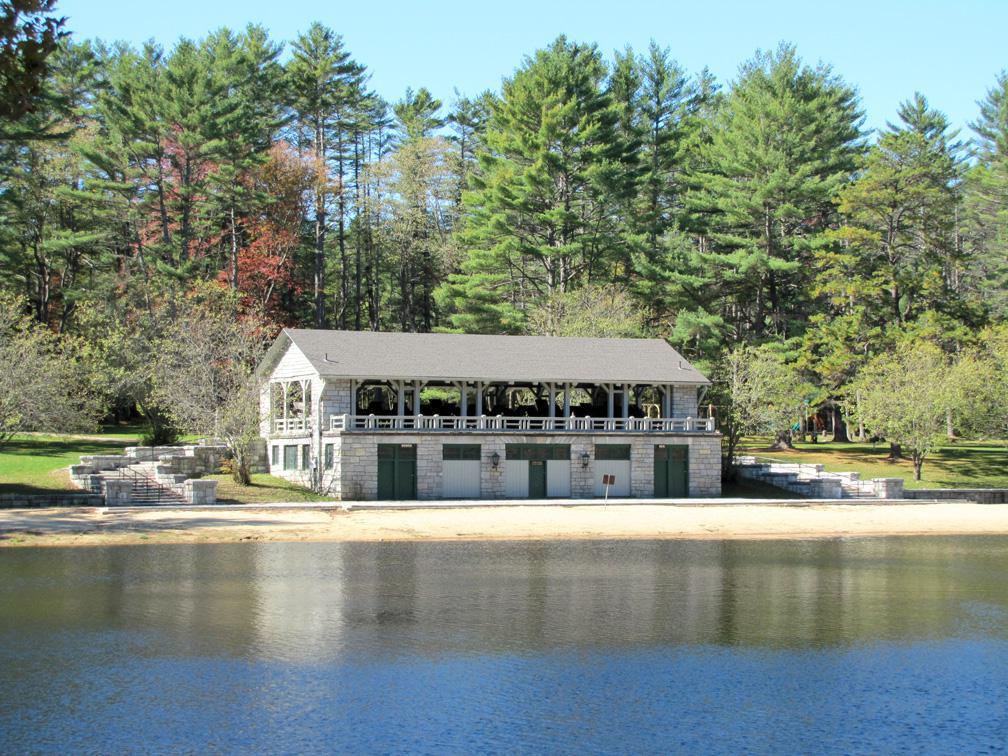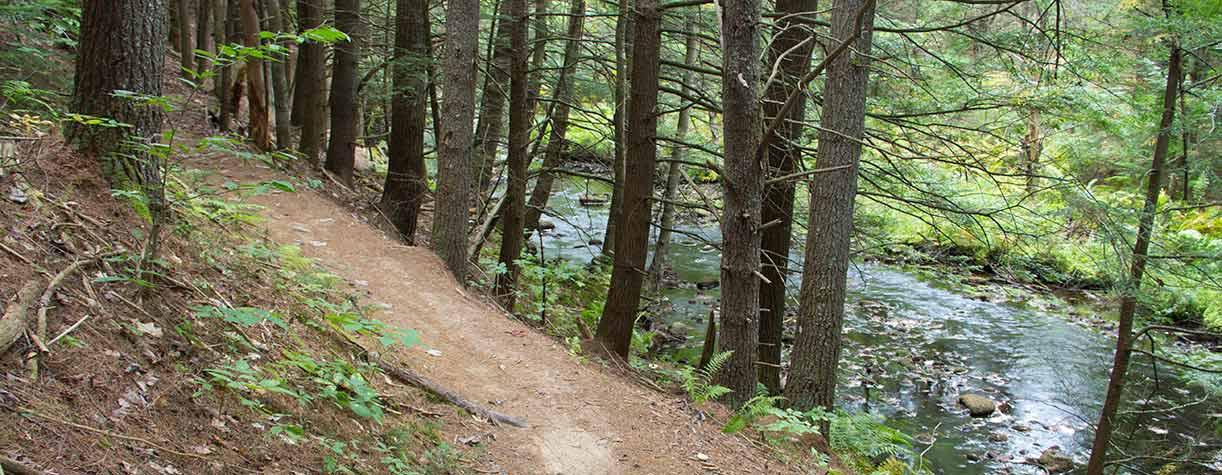The first image is the image on the left, the second image is the image on the right. Assess this claim about the two images: "There is a two story event house nestled into the wood looking over a beach.". Correct or not? Answer yes or no. Yes. The first image is the image on the left, the second image is the image on the right. Analyze the images presented: Is the assertion "An image shows a gray stone building with a straight peaked gray roof in front of a stretch of beach on a lake." valid? Answer yes or no. Yes. 